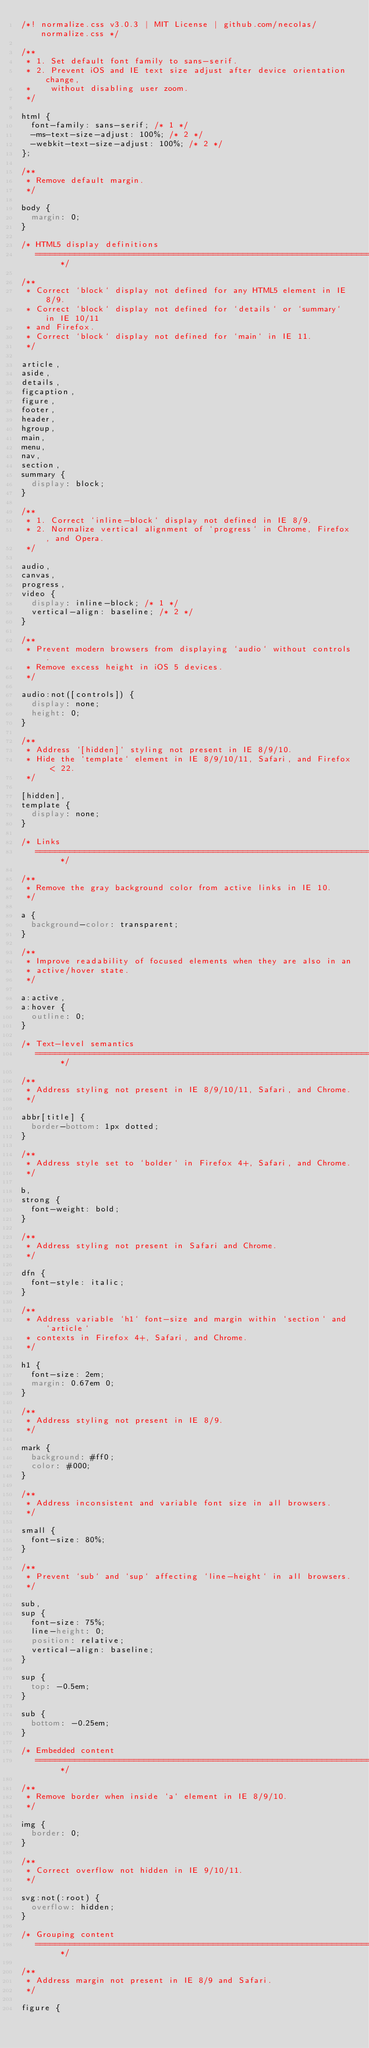<code> <loc_0><loc_0><loc_500><loc_500><_CSS_>/*! normalize.css v3.0.3 | MIT License | github.com/necolas/normalize.css */

/**
 * 1. Set default font family to sans-serif.
 * 2. Prevent iOS and IE text size adjust after device orientation change,
 *    without disabling user zoom.
 */

html {
  font-family: sans-serif; /* 1 */
  -ms-text-size-adjust: 100%; /* 2 */
  -webkit-text-size-adjust: 100%; /* 2 */
};

/**
 * Remove default margin.
 */

body {
  margin: 0;
}

/* HTML5 display definitions
   ========================================================================== */

/**
 * Correct `block` display not defined for any HTML5 element in IE 8/9.
 * Correct `block` display not defined for `details` or `summary` in IE 10/11
 * and Firefox.
 * Correct `block` display not defined for `main` in IE 11.
 */

article,
aside,
details,
figcaption,
figure,
footer,
header,
hgroup,
main,
menu,
nav,
section,
summary {
  display: block;
}

/**
 * 1. Correct `inline-block` display not defined in IE 8/9.
 * 2. Normalize vertical alignment of `progress` in Chrome, Firefox, and Opera.
 */

audio,
canvas,
progress,
video {
  display: inline-block; /* 1 */
  vertical-align: baseline; /* 2 */
}

/**
 * Prevent modern browsers from displaying `audio` without controls.
 * Remove excess height in iOS 5 devices.
 */

audio:not([controls]) {
  display: none;
  height: 0;
}

/**
 * Address `[hidden]` styling not present in IE 8/9/10.
 * Hide the `template` element in IE 8/9/10/11, Safari, and Firefox < 22.
 */

[hidden],
template {
  display: none;
}

/* Links
   ========================================================================== */

/**
 * Remove the gray background color from active links in IE 10.
 */

a {
  background-color: transparent;
}

/**
 * Improve readability of focused elements when they are also in an
 * active/hover state.
 */

a:active,
a:hover {
  outline: 0;
}

/* Text-level semantics
   ========================================================================== */

/**
 * Address styling not present in IE 8/9/10/11, Safari, and Chrome.
 */

abbr[title] {
  border-bottom: 1px dotted;
}

/**
 * Address style set to `bolder` in Firefox 4+, Safari, and Chrome.
 */

b,
strong {
  font-weight: bold;
}

/**
 * Address styling not present in Safari and Chrome.
 */

dfn {
  font-style: italic;
}

/**
 * Address variable `h1` font-size and margin within `section` and `article`
 * contexts in Firefox 4+, Safari, and Chrome.
 */

h1 {
  font-size: 2em;
  margin: 0.67em 0;
}

/**
 * Address styling not present in IE 8/9.
 */

mark {
  background: #ff0;
  color: #000;
}

/**
 * Address inconsistent and variable font size in all browsers.
 */

small {
  font-size: 80%;
}

/**
 * Prevent `sub` and `sup` affecting `line-height` in all browsers.
 */

sub,
sup {
  font-size: 75%;
  line-height: 0;
  position: relative;
  vertical-align: baseline;
}

sup {
  top: -0.5em;
}

sub {
  bottom: -0.25em;
}

/* Embedded content
   ========================================================================== */

/**
 * Remove border when inside `a` element in IE 8/9/10.
 */

img {
  border: 0;
}

/**
 * Correct overflow not hidden in IE 9/10/11.
 */

svg:not(:root) {
  overflow: hidden;
}

/* Grouping content
   ========================================================================== */

/**
 * Address margin not present in IE 8/9 and Safari.
 */

figure {</code> 